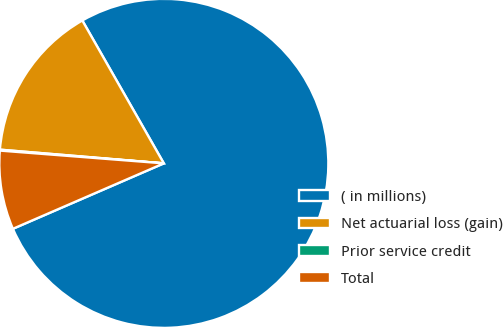<chart> <loc_0><loc_0><loc_500><loc_500><pie_chart><fcel>( in millions)<fcel>Net actuarial loss (gain)<fcel>Prior service credit<fcel>Total<nl><fcel>76.74%<fcel>15.42%<fcel>0.09%<fcel>7.75%<nl></chart> 